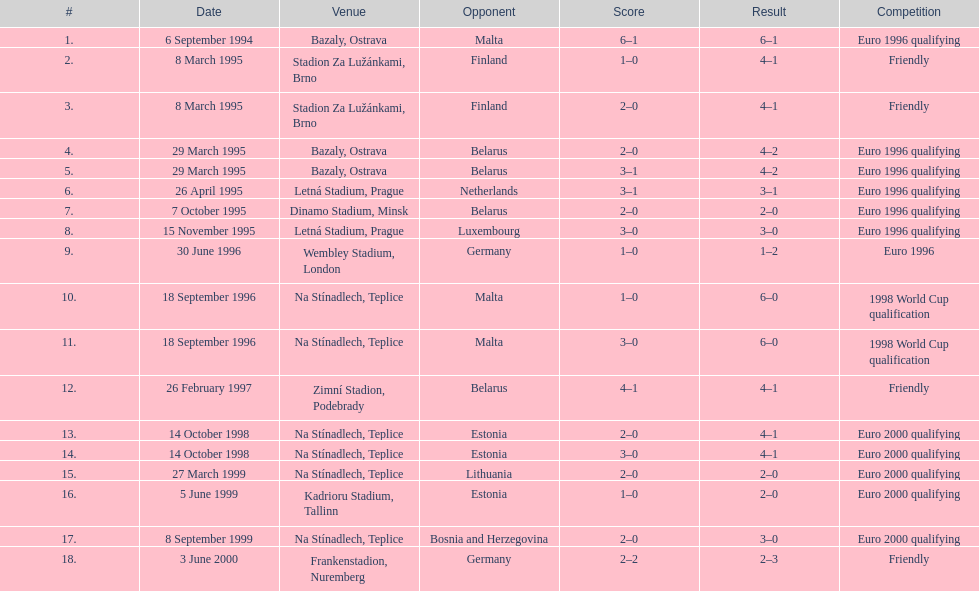What was the total number of games held in ostrava? 2. 